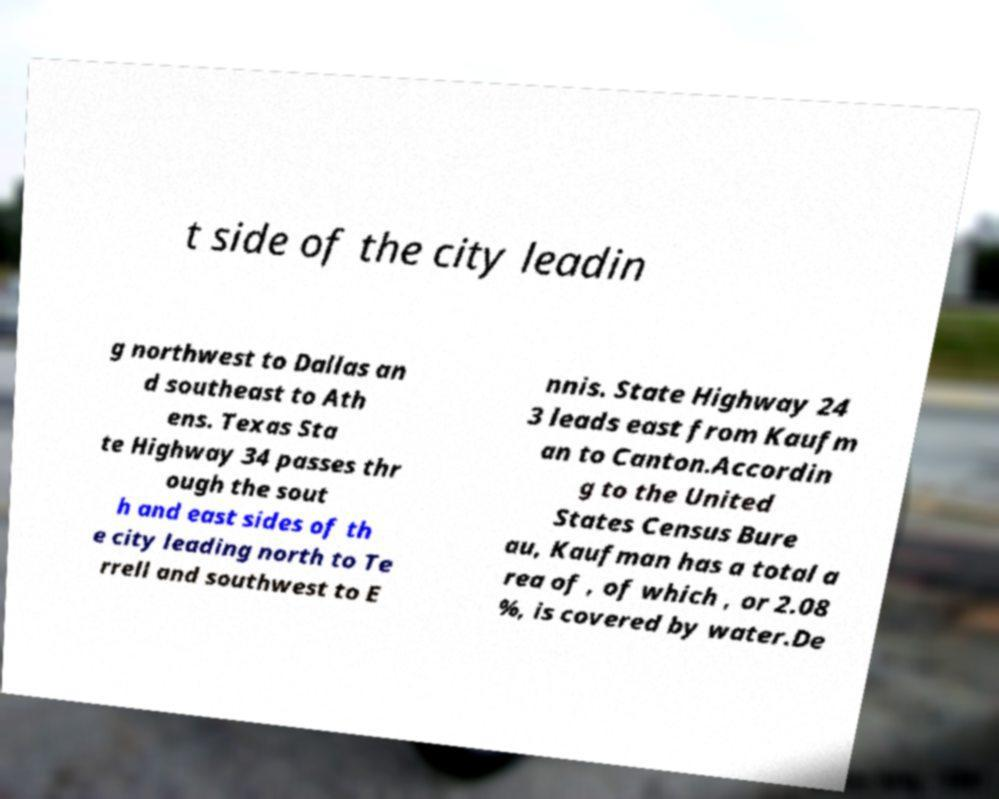Can you accurately transcribe the text from the provided image for me? t side of the city leadin g northwest to Dallas an d southeast to Ath ens. Texas Sta te Highway 34 passes thr ough the sout h and east sides of th e city leading north to Te rrell and southwest to E nnis. State Highway 24 3 leads east from Kaufm an to Canton.Accordin g to the United States Census Bure au, Kaufman has a total a rea of , of which , or 2.08 %, is covered by water.De 